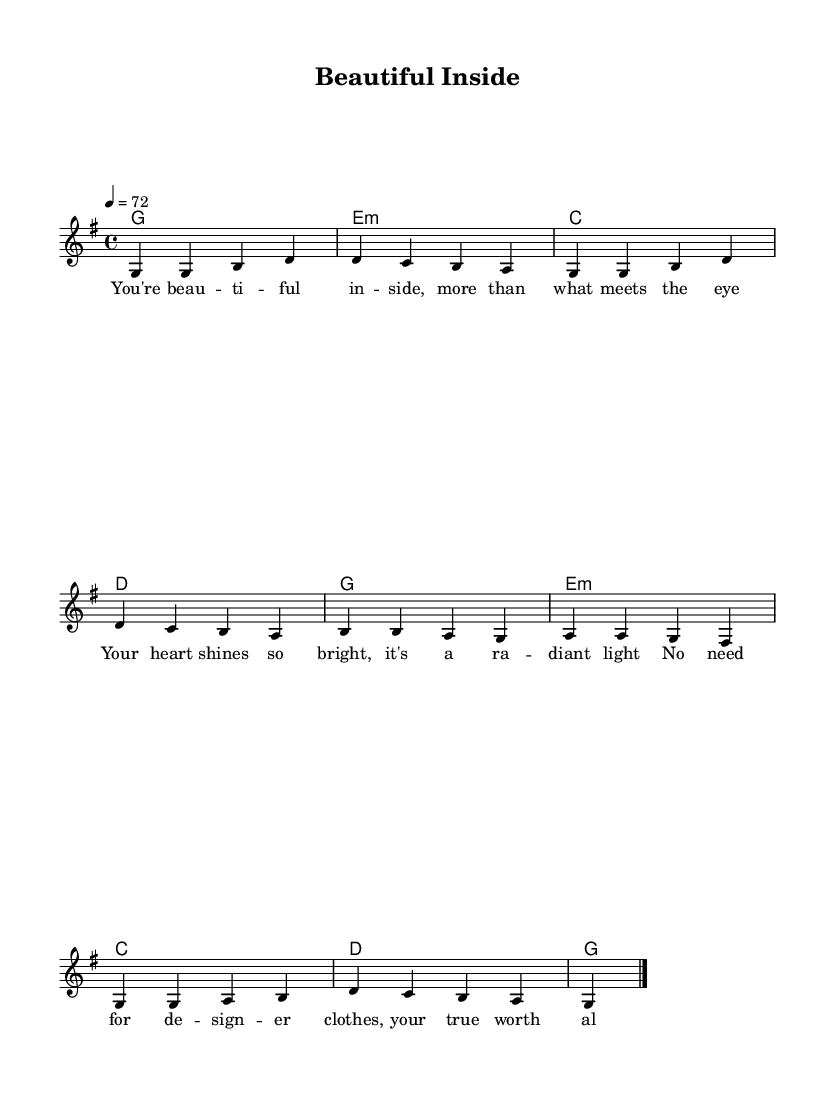What is the key signature of this music? The key signature is G major, which has one sharp (F#). You can tell by looking at the key signature located at the beginning of the staff, which indicates the notes that will have sharps or flats throughout the piece.
Answer: G major What is the time signature of this music? The time signature is 4/4, as shown at the beginning of the sheet music. This means that there are four beats in each measure and the quarter note receives one beat.
Answer: 4/4 What is the tempo indicated for this piece? The tempo is set at 72 beats per minute, shown in the tempo marking "4 = 72". This informs the performer how quickly to play the piece.
Answer: 72 How many measures are in the melody? There are eight measures in the melody. You can count the vertical bar lines in the staff; each bar line indicates the end of a measure.
Answer: Eight What is the primary theme expressed in the lyrics? The primary theme expressed in the lyrics is inner beauty. You can identify this by reading the lyrics which focus on the intrinsic worth and radiance of a person's heart rather than their outward appearance.
Answer: Inner beauty What is the harmonic structure of the piece? The harmonic structure consists of four chords: G major, E minor, C major, and D major, presented in a sequential pattern for each measure. This is gathered from analyzing the chord names alongside the melody.
Answer: G, E minor, C, D What does the repeated use of "you're beautiful inside" signify in the lyrics? The repeated phrase signifies a central affirmation of the song’s message, reinforcing the theme of valuing inner beauty. It emphasizes a key emotional takeaway from the song, inviting the listener to reflect on their own self-worth.
Answer: Affirmation 